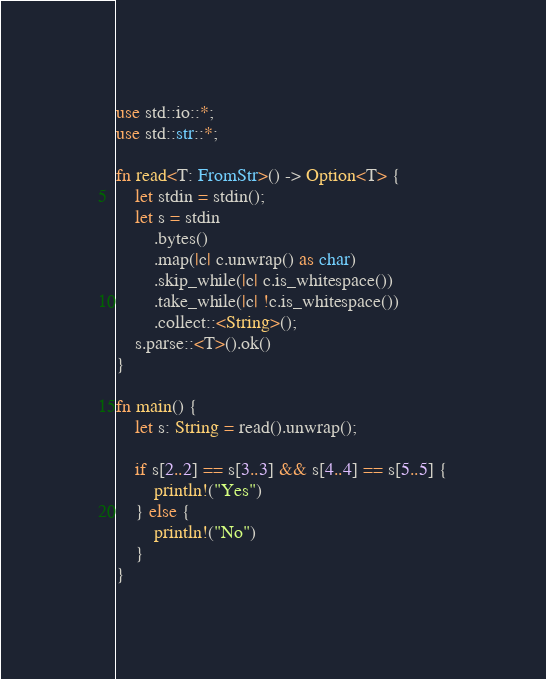<code> <loc_0><loc_0><loc_500><loc_500><_Rust_>use std::io::*;
use std::str::*;

fn read<T: FromStr>() -> Option<T> {
    let stdin = stdin();
    let s = stdin
        .bytes()
        .map(|c| c.unwrap() as char)
        .skip_while(|c| c.is_whitespace())
        .take_while(|c| !c.is_whitespace())
        .collect::<String>();
    s.parse::<T>().ok()
}

fn main() {
    let s: String = read().unwrap();

    if s[2..2] == s[3..3] && s[4..4] == s[5..5] {
        println!("Yes")
    } else {
        println!("No")
    }
}
</code> 